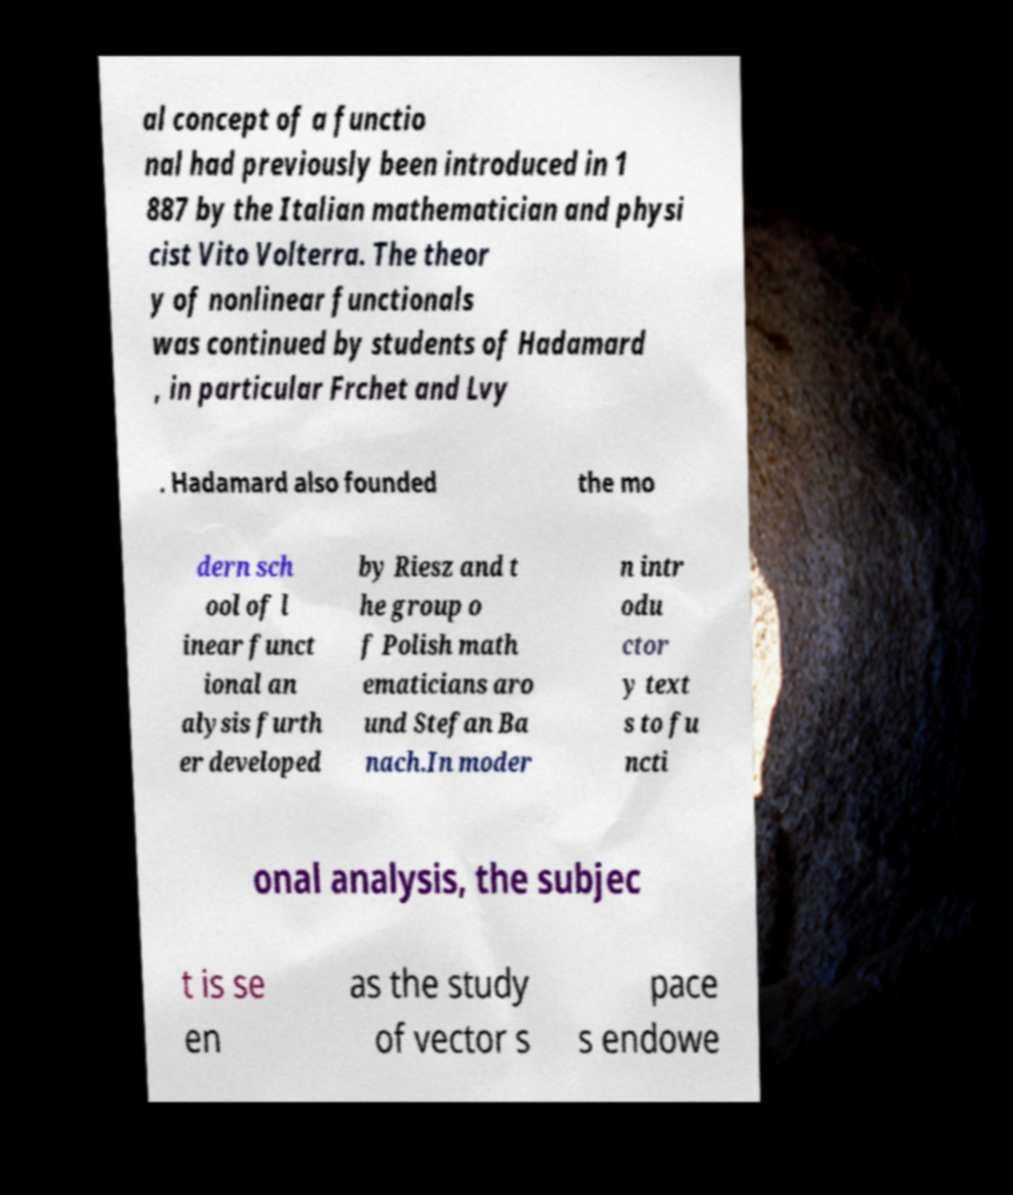There's text embedded in this image that I need extracted. Can you transcribe it verbatim? al concept of a functio nal had previously been introduced in 1 887 by the Italian mathematician and physi cist Vito Volterra. The theor y of nonlinear functionals was continued by students of Hadamard , in particular Frchet and Lvy . Hadamard also founded the mo dern sch ool of l inear funct ional an alysis furth er developed by Riesz and t he group o f Polish math ematicians aro und Stefan Ba nach.In moder n intr odu ctor y text s to fu ncti onal analysis, the subjec t is se en as the study of vector s pace s endowe 